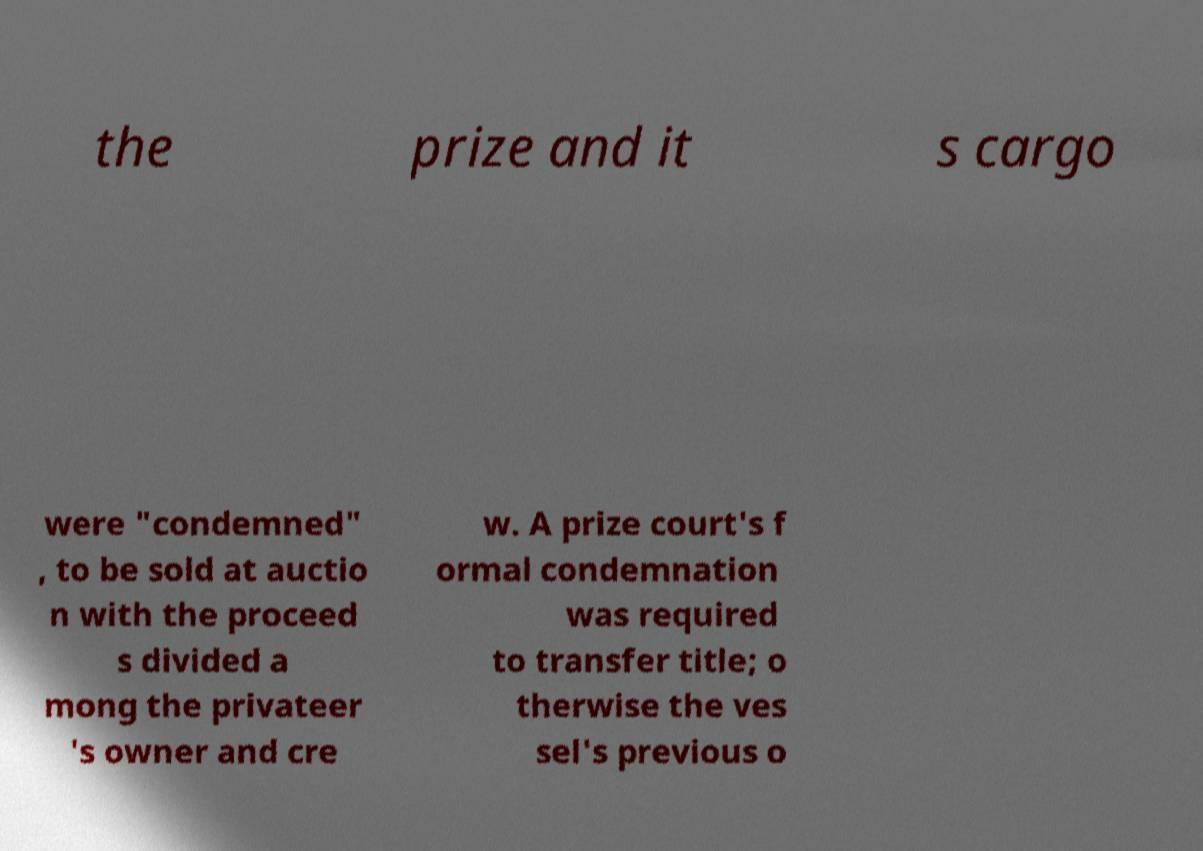Can you read and provide the text displayed in the image?This photo seems to have some interesting text. Can you extract and type it out for me? the prize and it s cargo were "condemned" , to be sold at auctio n with the proceed s divided a mong the privateer 's owner and cre w. A prize court's f ormal condemnation was required to transfer title; o therwise the ves sel's previous o 